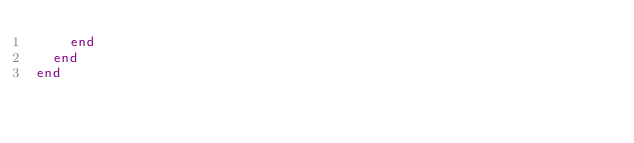Convert code to text. <code><loc_0><loc_0><loc_500><loc_500><_Ruby_>    end
  end
end
</code> 